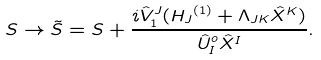<formula> <loc_0><loc_0><loc_500><loc_500>S \rightarrow { \tilde { S } } = S + \frac { i { { \hat { V } } _ { 1 } } ^ { J } ( { H _ { J } } ^ { ( 1 ) } + \Lambda _ { J K } { \hat { X } } ^ { K } ) } { { \hat { U } } _ { I } ^ { o } { \hat { X } } ^ { I } } .</formula> 